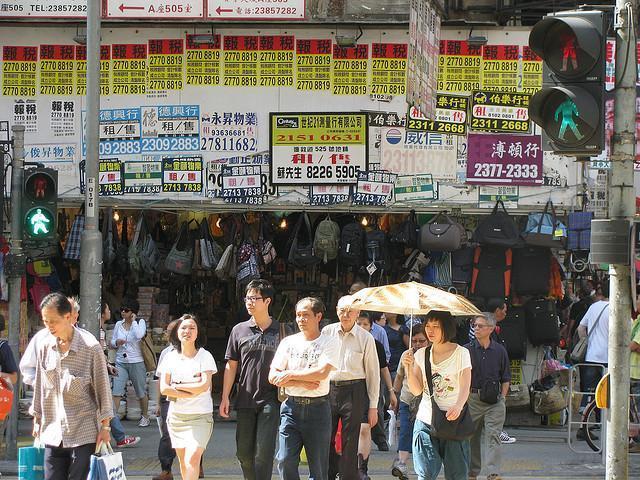How many people can be seen?
Give a very brief answer. 10. How many traffic lights are there?
Give a very brief answer. 2. How many cups are there?
Give a very brief answer. 0. 